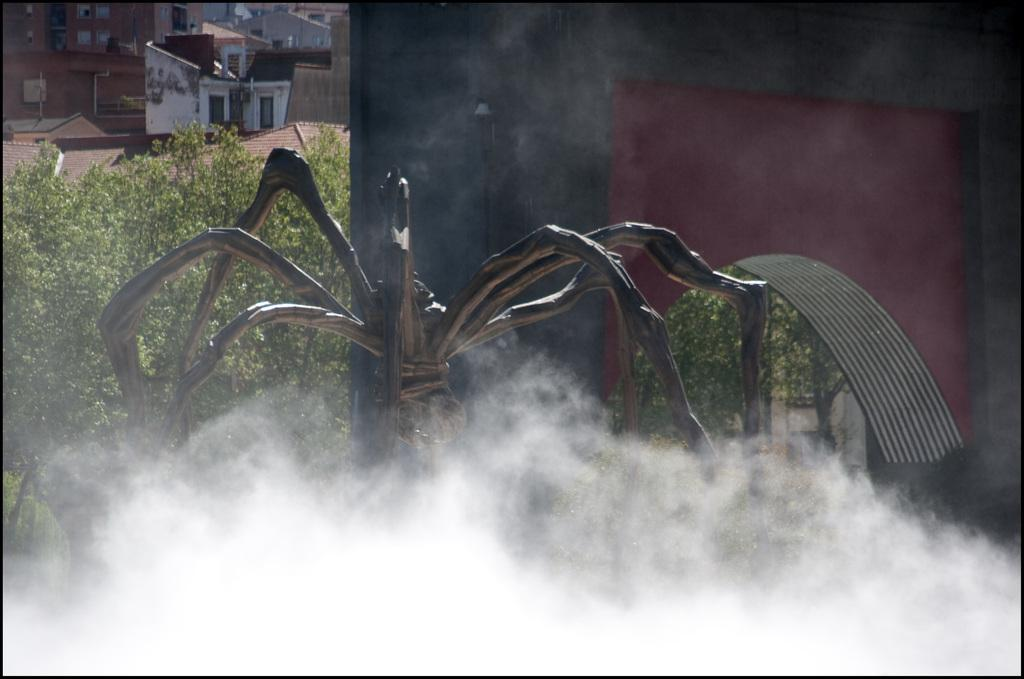What is the main subject of the image? There is a spider sculpture in the image. What can be seen in the background of the image? There are trees, walls, houses, buildings, and poles visible in the background of the image. Is there any indication of a specific time or season in the image? The presence of smoke visible at the bottom of the image might suggest a colder or wintery setting. What type of cork can be seen in the image? There is no cork present in the image. Is there any eggnog being served in the image? There is no indication of any food or beverages, including eggnog, in the image. 